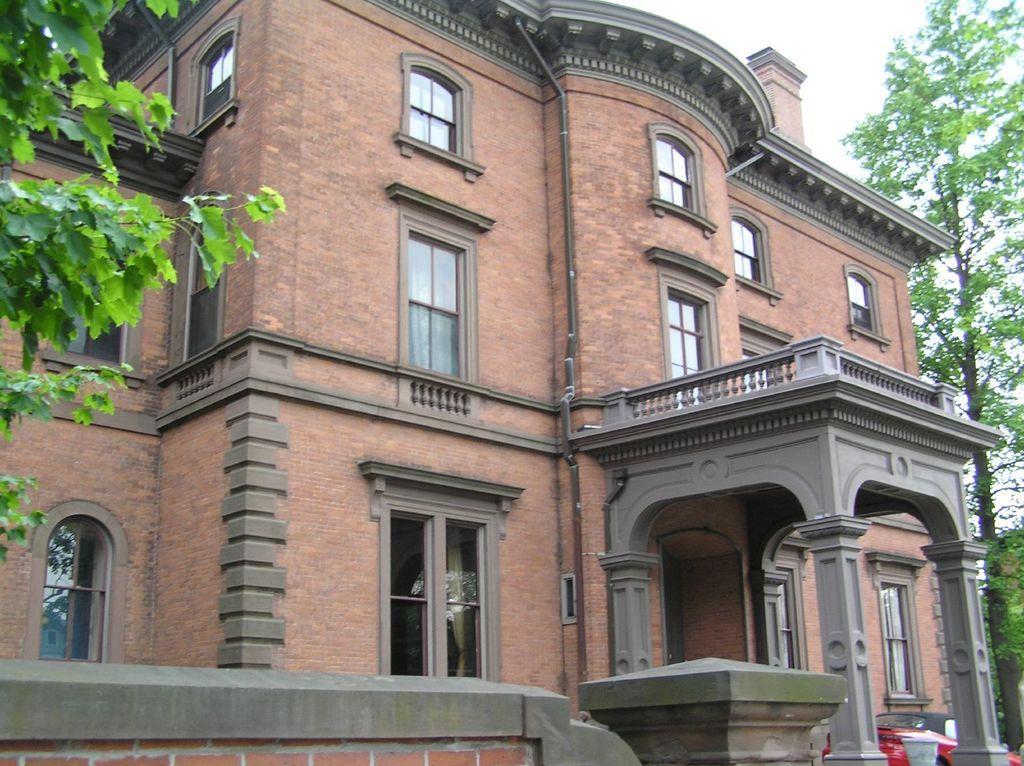In one or two sentences, can you explain what this image depicts? In this picture there is a brown color building with glass window. On the front bottom side there is a red color car parked in the portico. On the left side there is a tree leaves. 